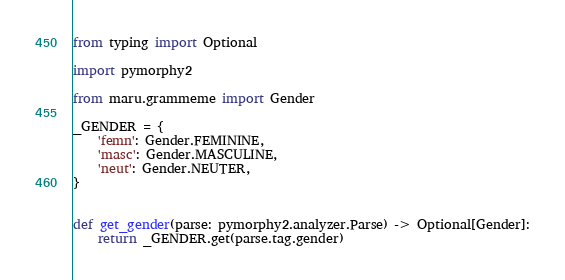Convert code to text. <code><loc_0><loc_0><loc_500><loc_500><_Python_>from typing import Optional

import pymorphy2

from maru.grammeme import Gender

_GENDER = {
    'femn': Gender.FEMININE,
    'masc': Gender.MASCULINE,
    'neut': Gender.NEUTER,
}


def get_gender(parse: pymorphy2.analyzer.Parse) -> Optional[Gender]:
    return _GENDER.get(parse.tag.gender)
</code> 